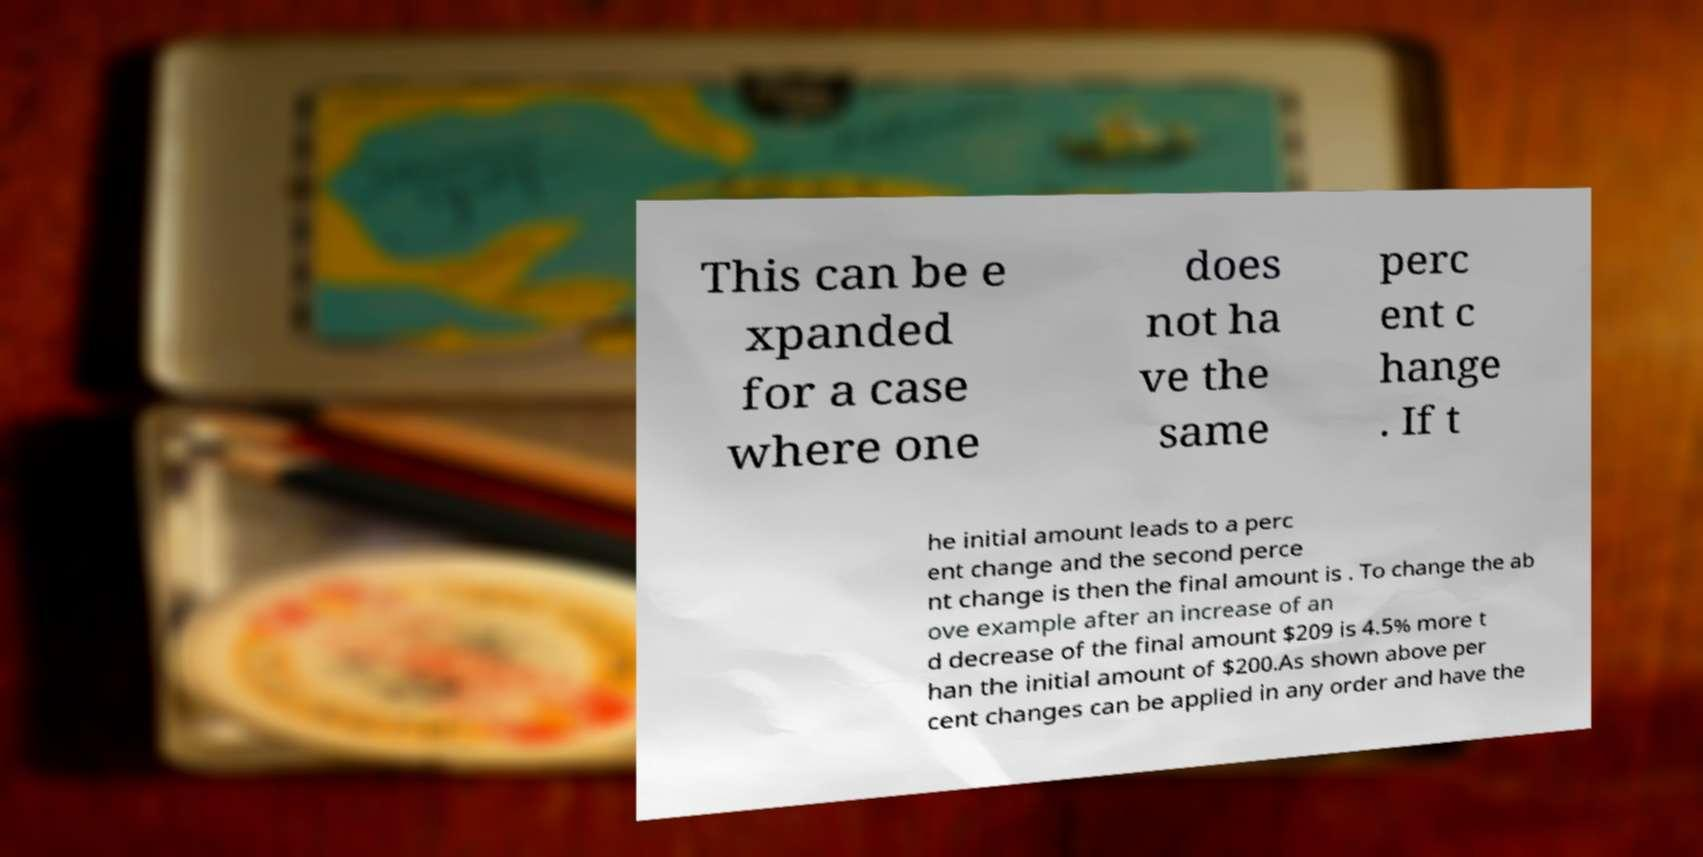Please read and relay the text visible in this image. What does it say? This can be e xpanded for a case where one does not ha ve the same perc ent c hange . If t he initial amount leads to a perc ent change and the second perce nt change is then the final amount is . To change the ab ove example after an increase of an d decrease of the final amount $209 is 4.5% more t han the initial amount of $200.As shown above per cent changes can be applied in any order and have the 